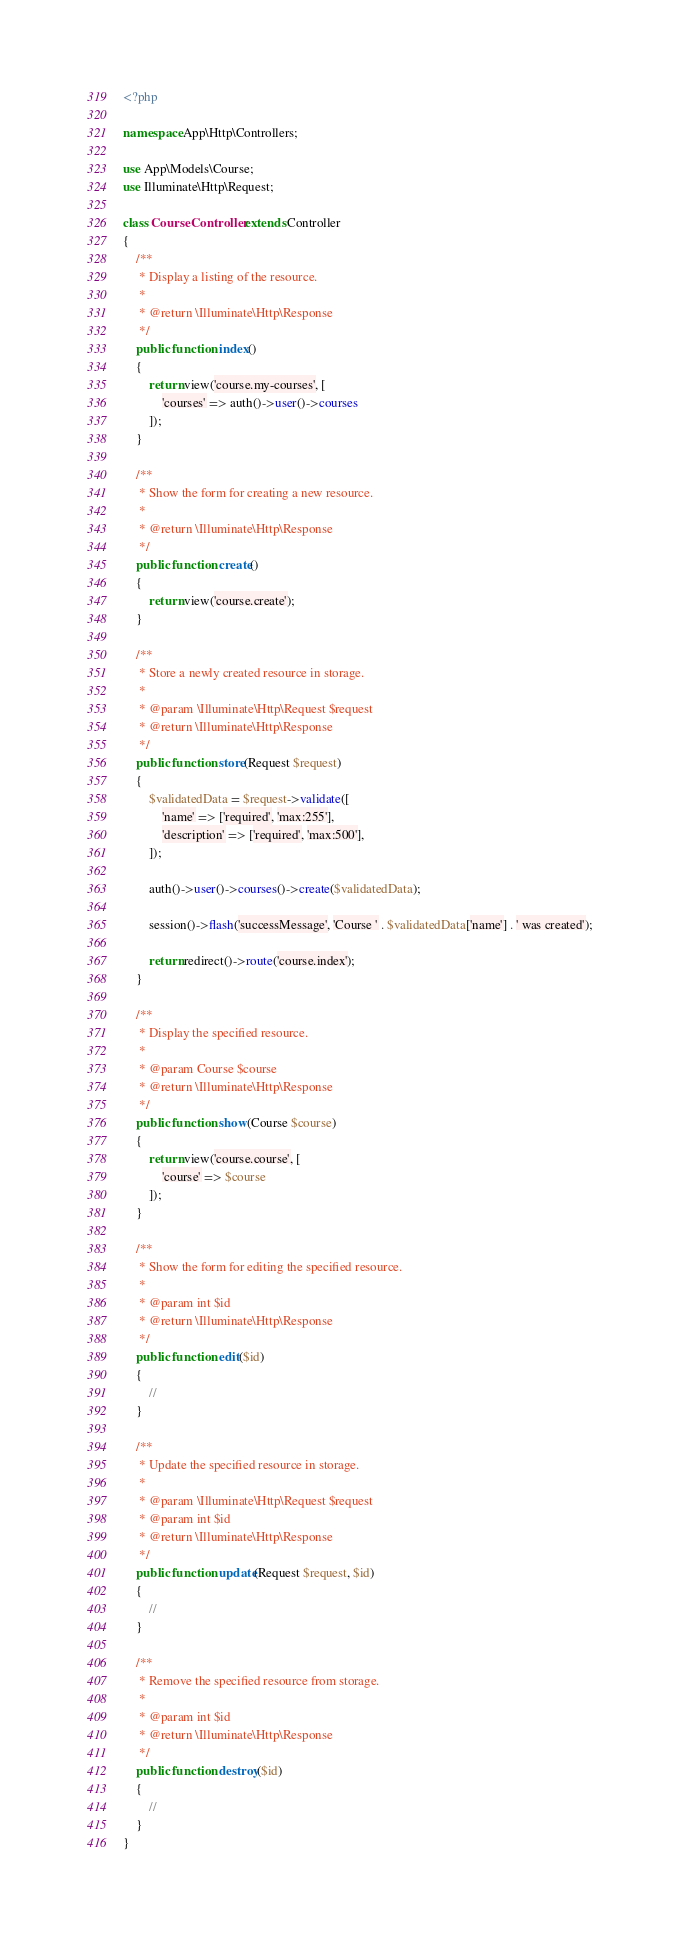<code> <loc_0><loc_0><loc_500><loc_500><_PHP_><?php

namespace App\Http\Controllers;

use App\Models\Course;
use Illuminate\Http\Request;

class CourseController extends Controller
{
    /**
     * Display a listing of the resource.
     *
     * @return \Illuminate\Http\Response
     */
    public function index()
    {
        return view('course.my-courses', [
            'courses' => auth()->user()->courses
        ]);
    }

    /**
     * Show the form for creating a new resource.
     *
     * @return \Illuminate\Http\Response
     */
    public function create()
    {
        return view('course.create');
    }

    /**
     * Store a newly created resource in storage.
     *
     * @param \Illuminate\Http\Request $request
     * @return \Illuminate\Http\Response
     */
    public function store(Request $request)
    {
        $validatedData = $request->validate([
            'name' => ['required', 'max:255'],
            'description' => ['required', 'max:500'],
        ]);

        auth()->user()->courses()->create($validatedData);

        session()->flash('successMessage', 'Course ' . $validatedData['name'] . ' was created');

        return redirect()->route('course.index');
    }

    /**
     * Display the specified resource.
     *
     * @param Course $course
     * @return \Illuminate\Http\Response
     */
    public function show(Course $course)
    {
        return view('course.course', [
            'course' => $course
        ]);
    }

    /**
     * Show the form for editing the specified resource.
     *
     * @param int $id
     * @return \Illuminate\Http\Response
     */
    public function edit($id)
    {
        //
    }

    /**
     * Update the specified resource in storage.
     *
     * @param \Illuminate\Http\Request $request
     * @param int $id
     * @return \Illuminate\Http\Response
     */
    public function update(Request $request, $id)
    {
        //
    }

    /**
     * Remove the specified resource from storage.
     *
     * @param int $id
     * @return \Illuminate\Http\Response
     */
    public function destroy($id)
    {
        //
    }
}
</code> 